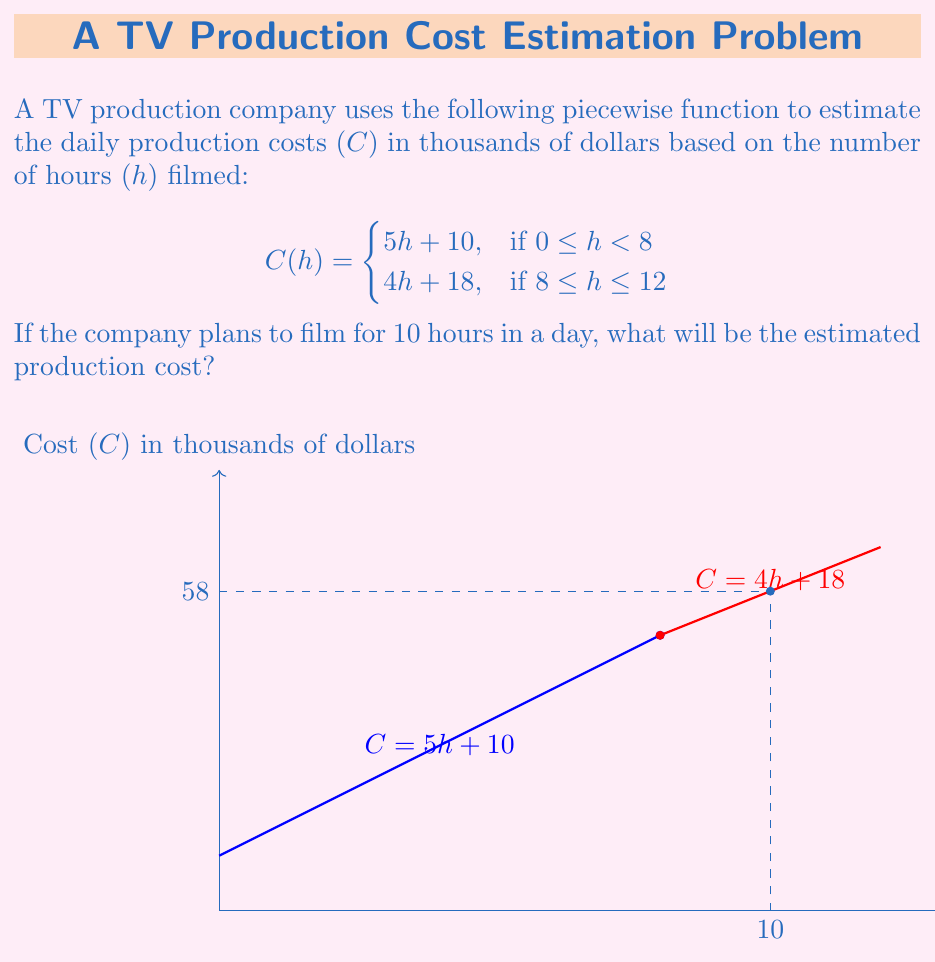Show me your answer to this math problem. To solve this problem, we need to follow these steps:

1) First, determine which piece of the function to use. Since the company plans to film for 10 hours, and 10 is in the interval $[8, 12]$, we'll use the second piece of the function:

   $$C(h) = 4h + 18$$

2) Now, we substitute h = 10 into this equation:

   $$C(10) = 4(10) + 18$$

3) Let's calculate:
   
   $$C(10) = 40 + 18 = 58$$

4) Therefore, the estimated production cost for 10 hours of filming is 58 thousand dollars.

Note: The graph visually confirms our calculation. We can see that the point (10, 58) lies on the red line representing the function for 8 ≤ h ≤ 12.
Answer: $58,000 